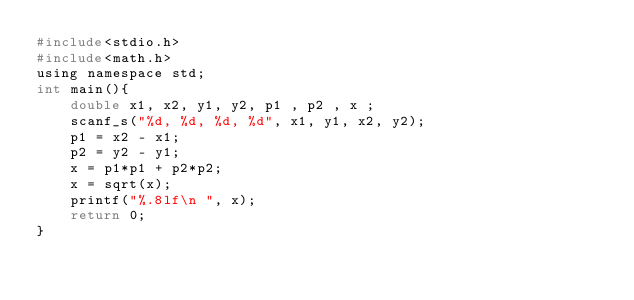<code> <loc_0><loc_0><loc_500><loc_500><_C_>#include<stdio.h>
#include<math.h>
using namespace std;
int main(){
	double x1, x2, y1, y2, p1 , p2 , x ;
	scanf_s("%d, %d, %d, %d", x1, y1, x2, y2);
	p1 = x2 - x1;
	p2 = y2 - y1;
	x = p1*p1 + p2*p2;
	x = sqrt(x);
	printf("%.8lf\n ", x);
	return 0;
}</code> 